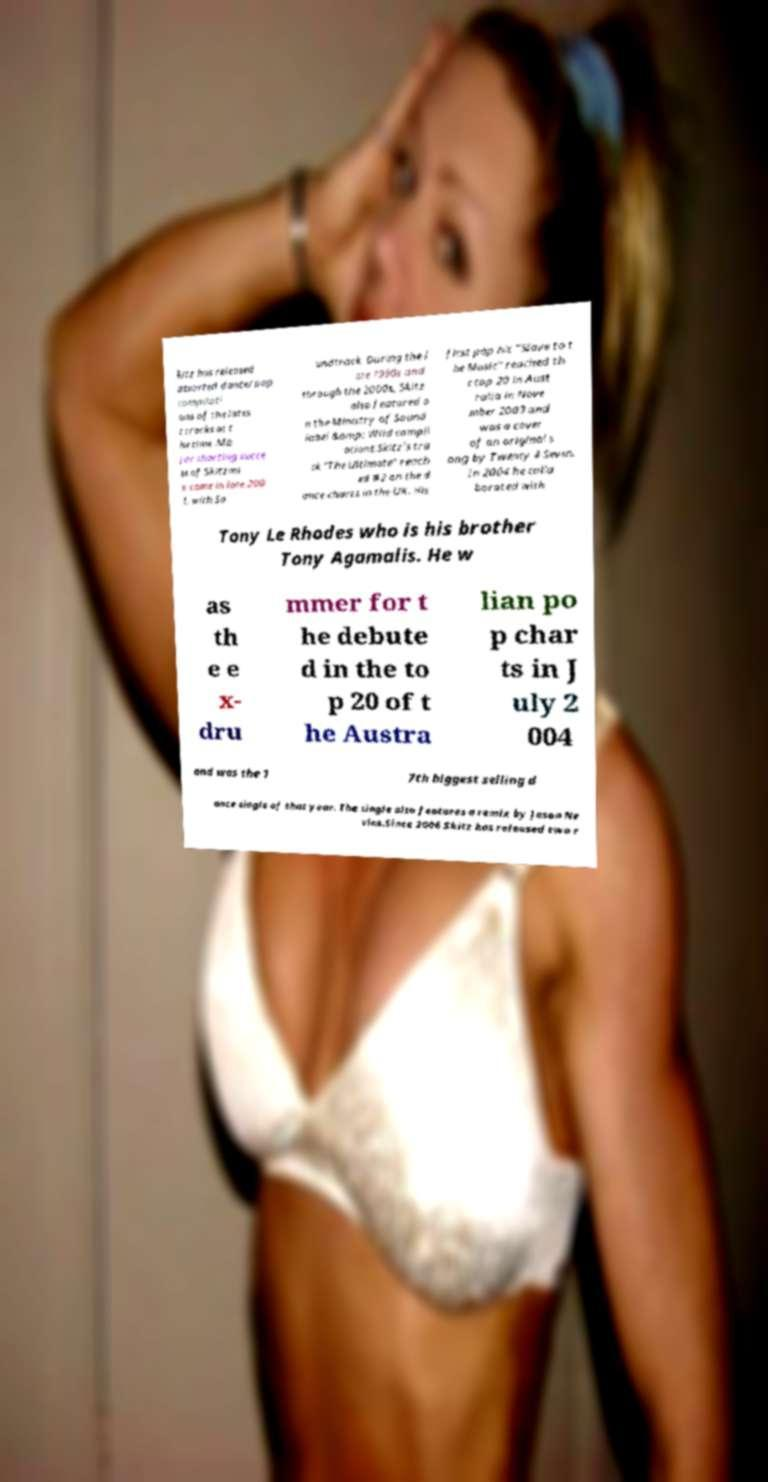Can you read and provide the text displayed in the image?This photo seems to have some interesting text. Can you extract and type it out for me? kitz has released assorted dance/pop compilati ons of the lates t tracks at t he time .Ma jor charting succe ss of Skitzmi x came in late 200 1, with So undtrack. During the l ate 1990s and through the 2000s, Skitz also featured o n the Ministry of Sound label &amp; Wild compil ations.Skitz's tra ck "The Ultimate" reach ed #2 on the d ance charts in the UK. His first pop hit "Slave to t he Music" reached th e top 20 in Aust ralia in Nove mber 2003 and was a cover of an original s ong by Twenty 4 Seven. In 2004 he colla borated with Tony Le Rhodes who is his brother Tony Agamalis. He w as th e e x- dru mmer for t he debute d in the to p 20 of t he Austra lian po p char ts in J uly 2 004 and was the 1 7th biggest selling d ance single of that year. The single also features a remix by Jason Ne vins.Since 2006 Skitz has released two r 